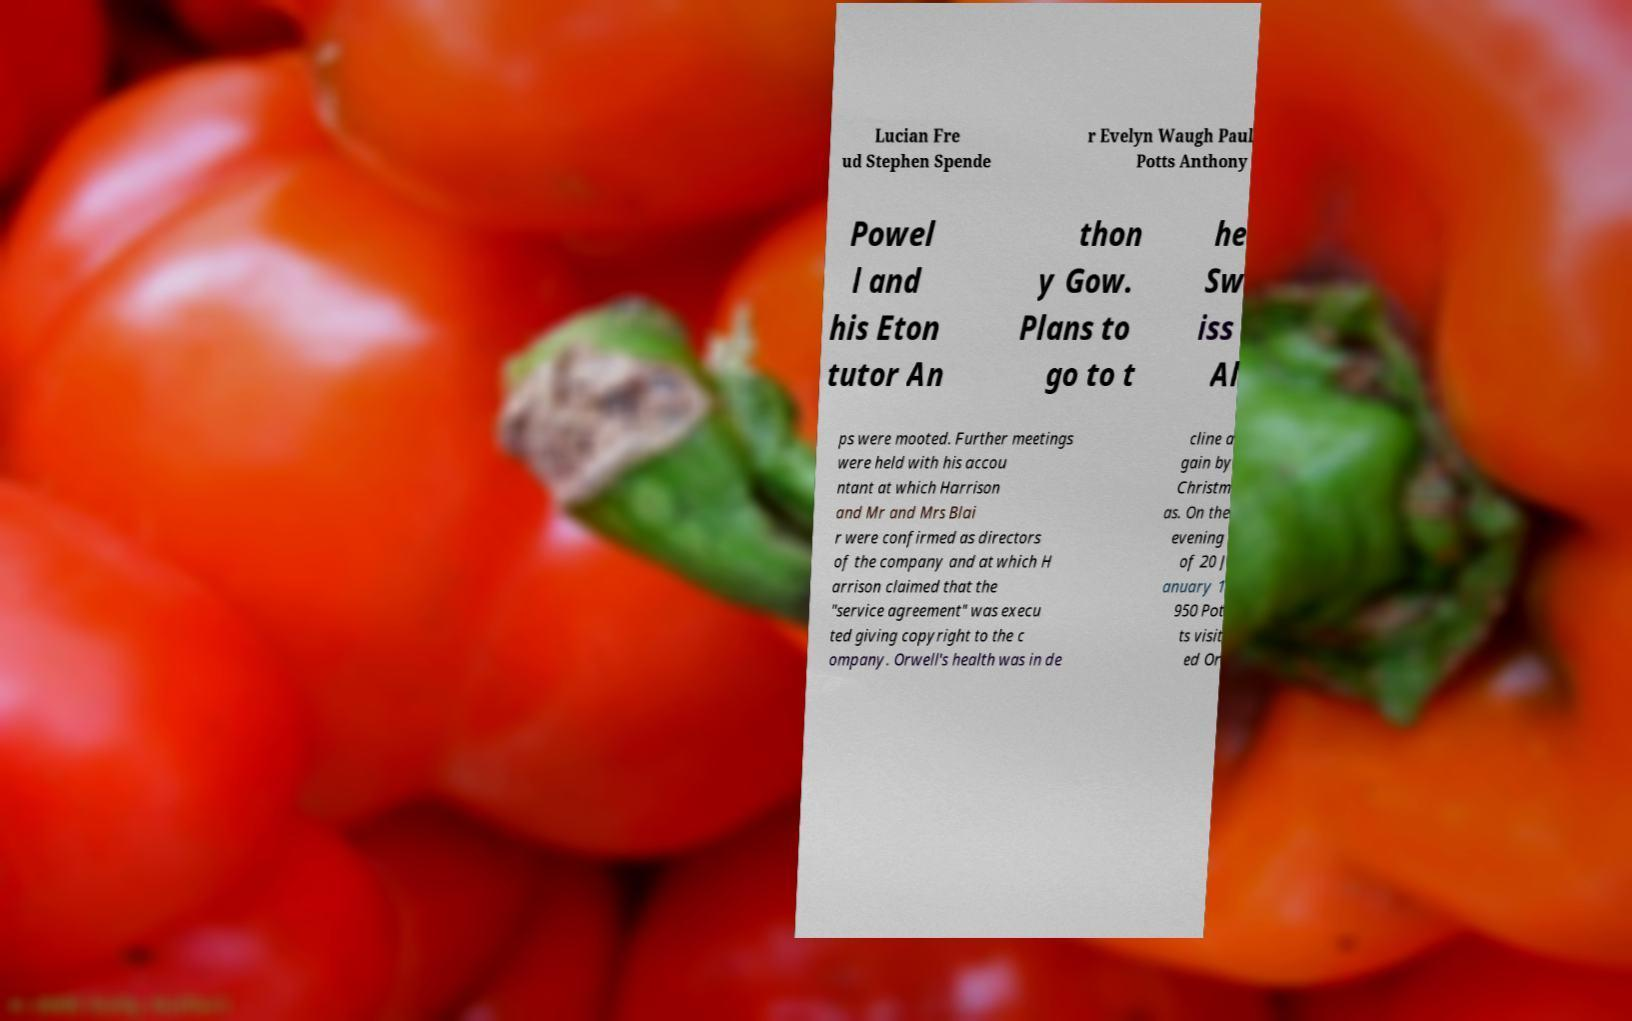Please identify and transcribe the text found in this image. Lucian Fre ud Stephen Spende r Evelyn Waugh Paul Potts Anthony Powel l and his Eton tutor An thon y Gow. Plans to go to t he Sw iss Al ps were mooted. Further meetings were held with his accou ntant at which Harrison and Mr and Mrs Blai r were confirmed as directors of the company and at which H arrison claimed that the "service agreement" was execu ted giving copyright to the c ompany. Orwell's health was in de cline a gain by Christm as. On the evening of 20 J anuary 1 950 Pot ts visit ed Or 